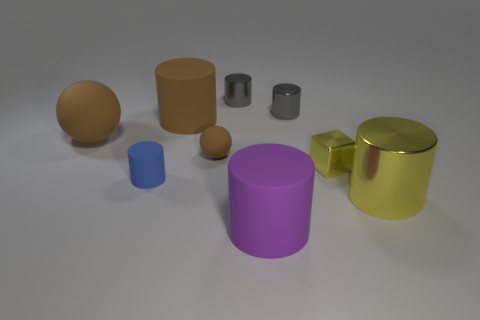What size is the purple object that is the same material as the blue cylinder?
Offer a very short reply. Large. How many tiny metallic cubes have the same color as the tiny ball?
Provide a short and direct response. 0. Are there any large red metallic balls?
Your answer should be compact. No. Does the blue thing have the same shape as the yellow metal thing on the right side of the yellow block?
Give a very brief answer. Yes. There is a thing on the left side of the small cylinder that is in front of the big brown thing that is in front of the brown cylinder; what color is it?
Ensure brevity in your answer.  Brown. Are there any brown rubber objects in front of the small brown rubber sphere?
Offer a terse response. No. There is a cylinder that is the same color as the small cube; what size is it?
Keep it short and to the point. Large. Is there a purple cylinder made of the same material as the small cube?
Your answer should be very brief. No. The small matte sphere is what color?
Provide a short and direct response. Brown. Does the rubber object to the left of the blue thing have the same shape as the tiny brown rubber object?
Your answer should be very brief. Yes. 